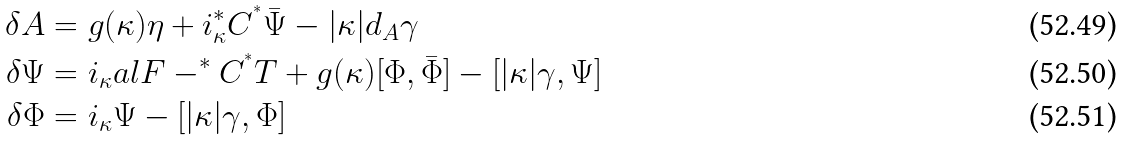<formula> <loc_0><loc_0><loc_500><loc_500>\delta A & = g ( \kappa ) \eta + i _ { \kappa } ^ { * } C ^ { ^ { * } } \bar { \Psi } - | \kappa | d _ { A } \gamma \\ \delta \Psi & = i _ { \kappa } a l { F - ^ { * } C ^ { ^ { * } } T } + g ( \kappa ) [ \Phi , \bar { \Phi } ] - [ | \kappa | \gamma , \Psi ] \\ \delta \Phi & = i _ { \kappa } \Psi - [ | \kappa | \gamma , \Phi ]</formula> 